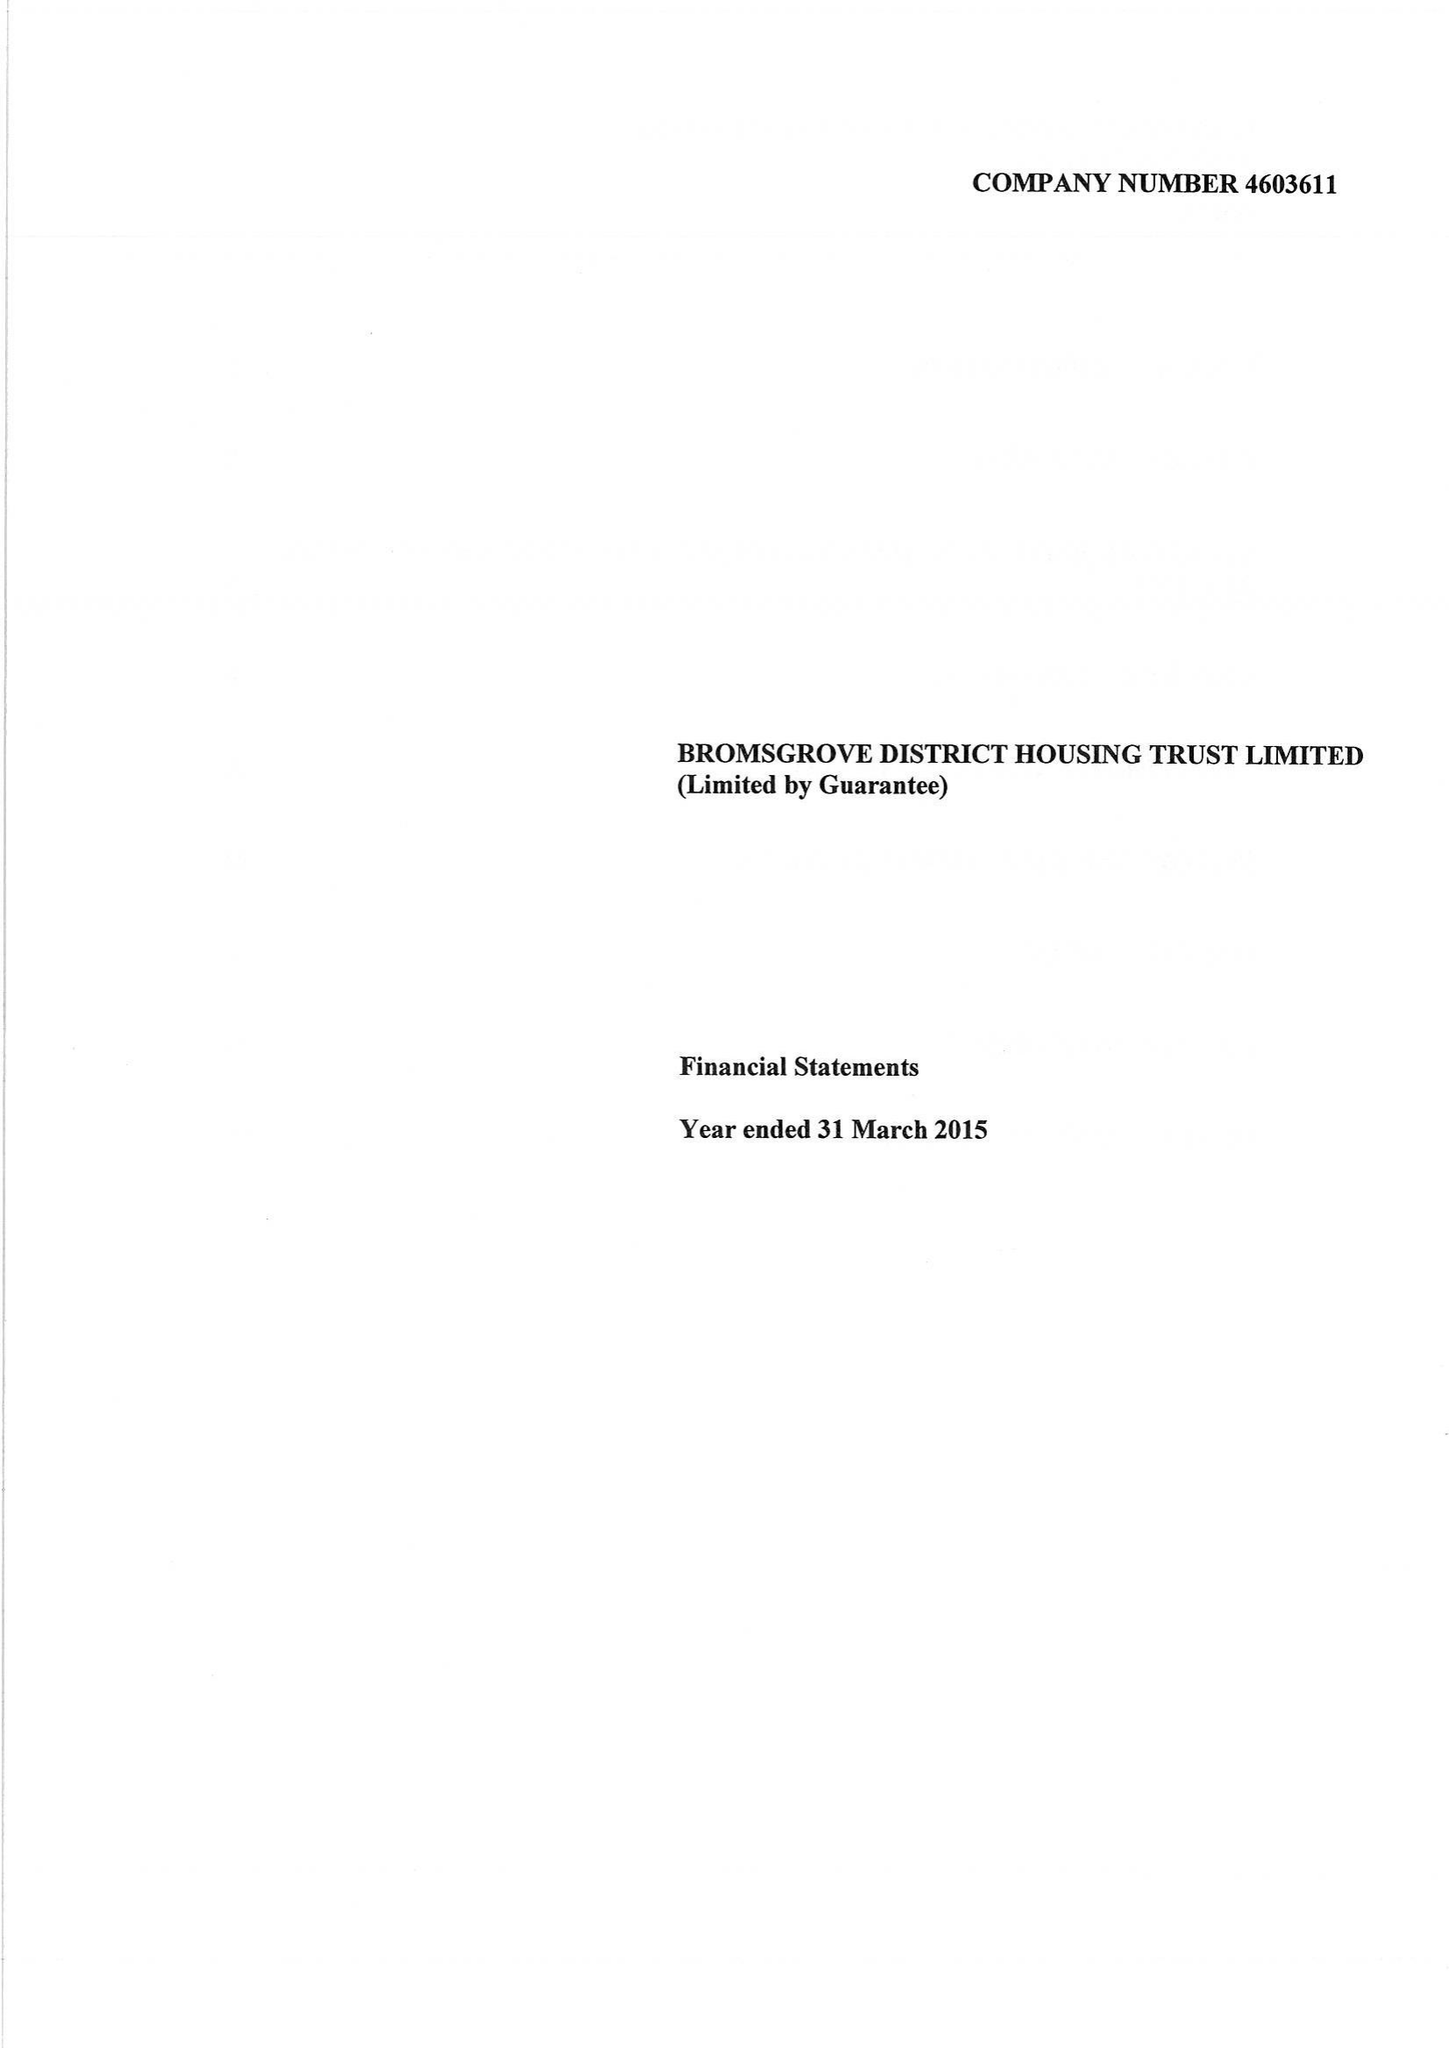What is the value for the address__street_line?
Answer the question using a single word or phrase. BROMSGROVE 